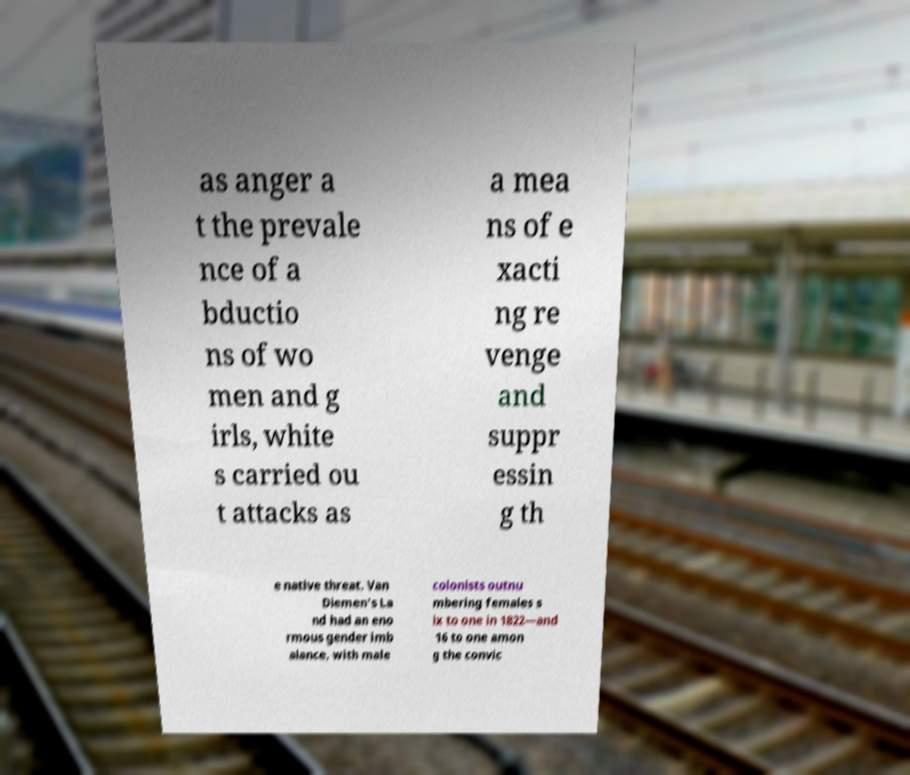Could you assist in decoding the text presented in this image and type it out clearly? as anger a t the prevale nce of a bductio ns of wo men and g irls, white s carried ou t attacks as a mea ns of e xacti ng re venge and suppr essin g th e native threat. Van Diemen's La nd had an eno rmous gender imb alance, with male colonists outnu mbering females s ix to one in 1822—and 16 to one amon g the convic 